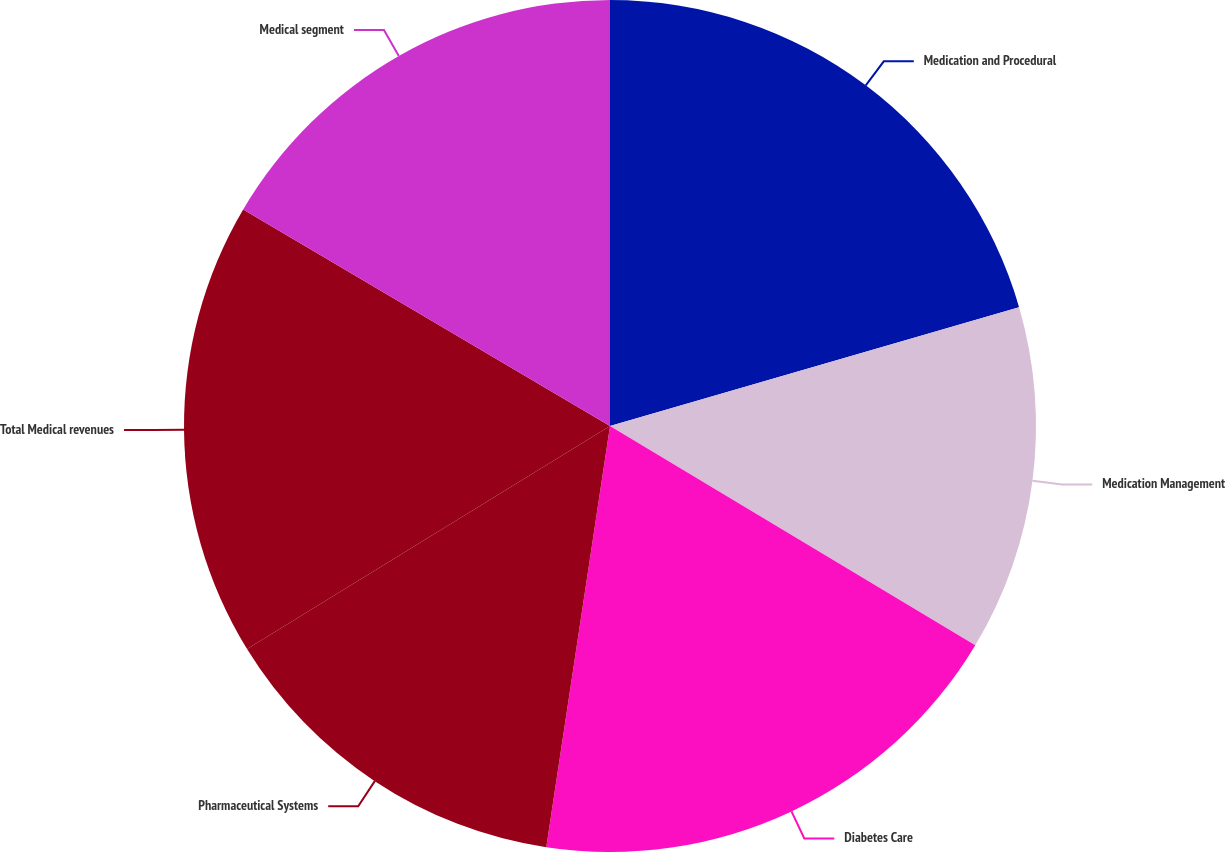<chart> <loc_0><loc_0><loc_500><loc_500><pie_chart><fcel>Medication and Procedural<fcel>Medication Management<fcel>Diabetes Care<fcel>Pharmaceutical Systems<fcel>Total Medical revenues<fcel>Medical segment<nl><fcel>20.5%<fcel>13.1%<fcel>18.79%<fcel>13.84%<fcel>17.26%<fcel>16.51%<nl></chart> 